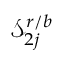Convert formula to latex. <formula><loc_0><loc_0><loc_500><loc_500>\mathcal { S } _ { 2 j } ^ { r / b }</formula> 